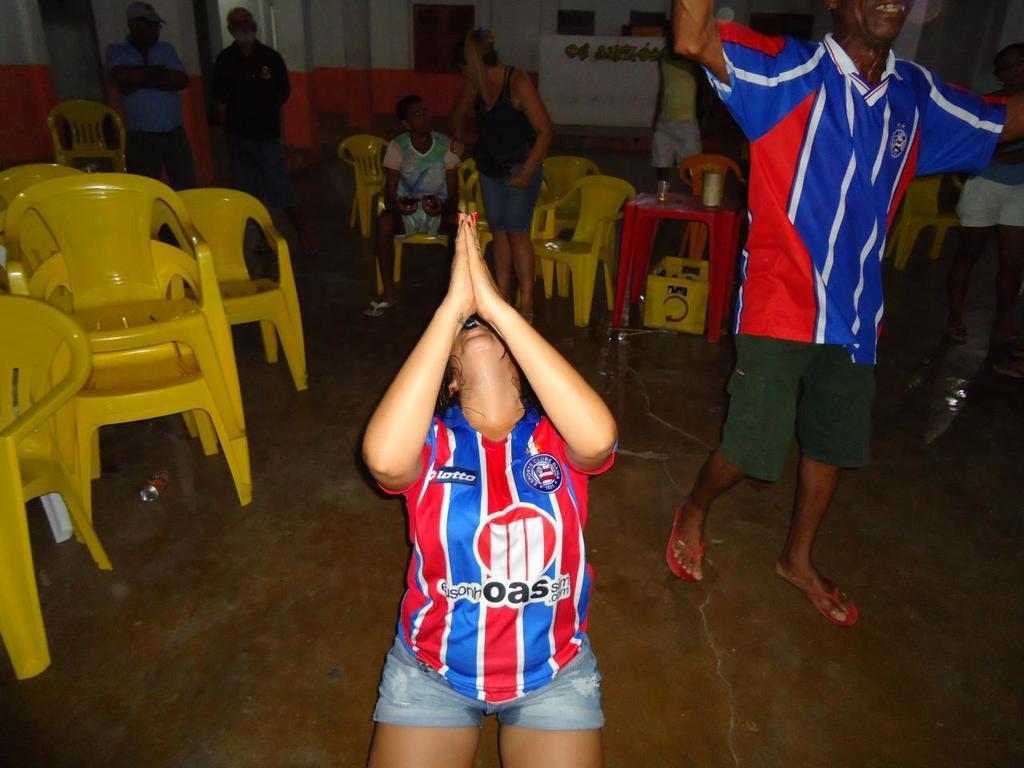Can you describe this image briefly? In this picture dressed in a football shirt is waving her hand. In the background we observe many chairs and people standing. 